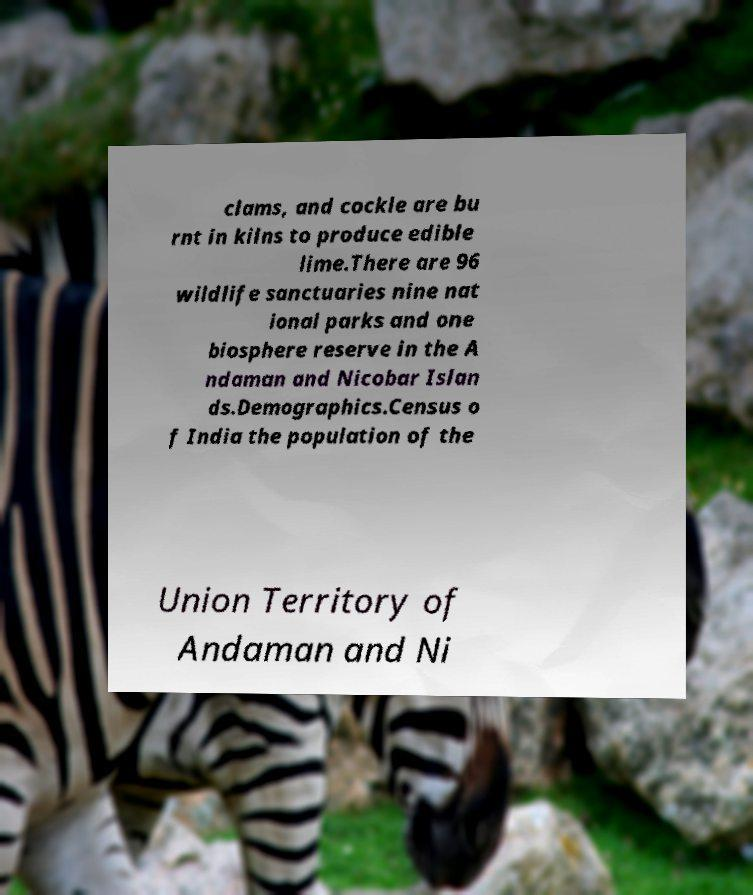There's text embedded in this image that I need extracted. Can you transcribe it verbatim? clams, and cockle are bu rnt in kilns to produce edible lime.There are 96 wildlife sanctuaries nine nat ional parks and one biosphere reserve in the A ndaman and Nicobar Islan ds.Demographics.Census o f India the population of the Union Territory of Andaman and Ni 